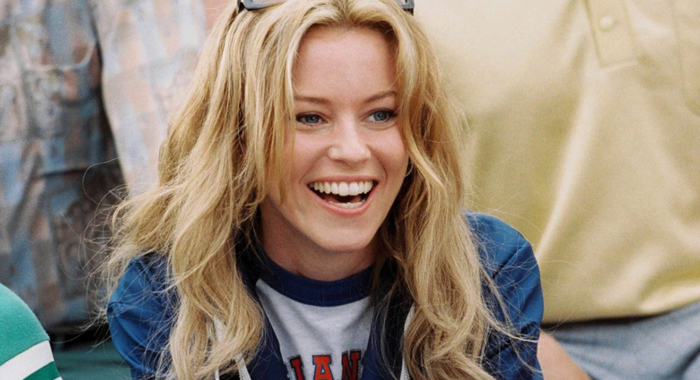Can you elaborate on the elements of the picture provided? The image features a woman with a joyful expression, capturing a moment of laughter. She is dressed in a blue and white baseball shirt with the initials 'LA', suggesting a sports or city theme, possibly related to Los Angeles. Her blonde hair falls loosely around her shoulders, enhancing her casual appearance. The background is blurred but shows tones of blue and green, contributing to a vibrant yet relaxed atmosphere. This scene might evoke themes of leisure or fan culture, depicting a candid and lighthearted moment. 